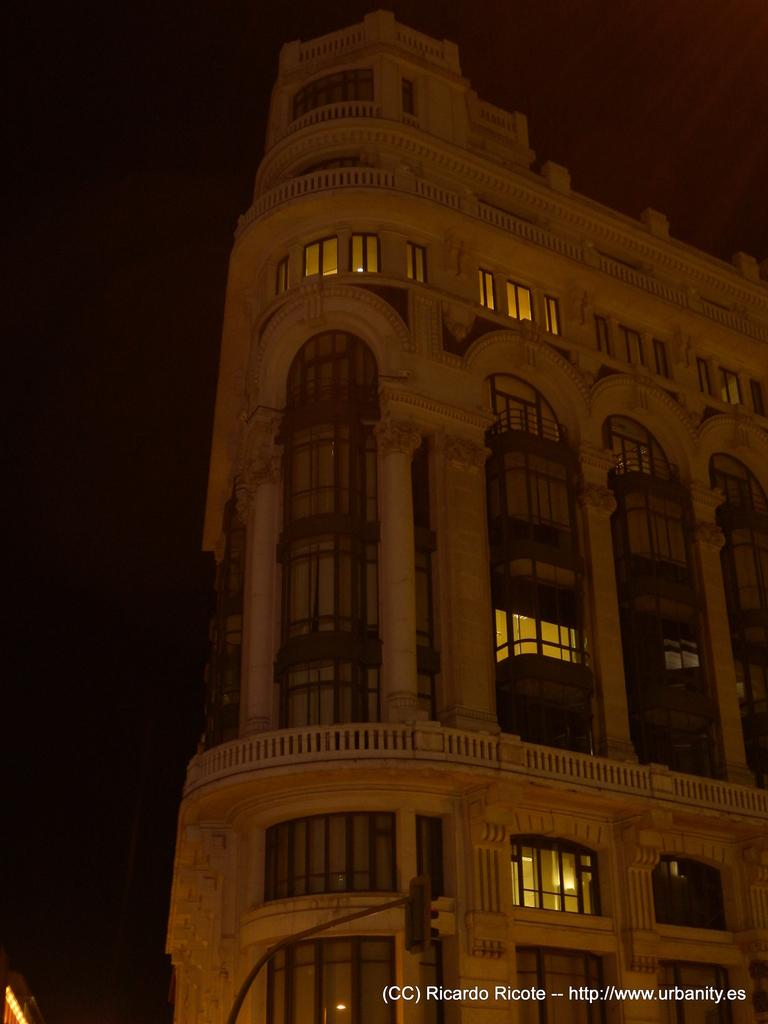What is the main subject of the image? The main subject of the image is a building. Can you describe the building's appearance? The building has many windows. When was the image taken? The image was taken at night. How does the building's growth change during the day? The image does not show any growth of the building, and the question of how it changes during the day cannot be answered based on the information provided. 